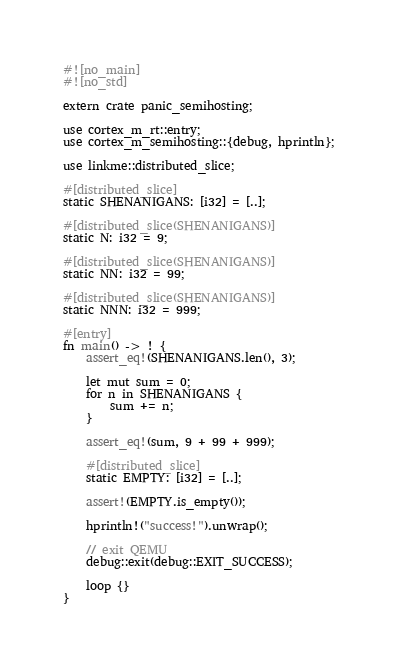Convert code to text. <code><loc_0><loc_0><loc_500><loc_500><_Rust_>#![no_main]
#![no_std]

extern crate panic_semihosting;

use cortex_m_rt::entry;
use cortex_m_semihosting::{debug, hprintln};

use linkme::distributed_slice;

#[distributed_slice]
static SHENANIGANS: [i32] = [..];

#[distributed_slice(SHENANIGANS)]
static N: i32 = 9;

#[distributed_slice(SHENANIGANS)]
static NN: i32 = 99;

#[distributed_slice(SHENANIGANS)]
static NNN: i32 = 999;

#[entry]
fn main() -> ! {
    assert_eq!(SHENANIGANS.len(), 3);

    let mut sum = 0;
    for n in SHENANIGANS {
        sum += n;
    }

    assert_eq!(sum, 9 + 99 + 999);

    #[distributed_slice]
    static EMPTY: [i32] = [..];

    assert!(EMPTY.is_empty());

    hprintln!("success!").unwrap();

    // exit QEMU
    debug::exit(debug::EXIT_SUCCESS);

    loop {}
}
</code> 